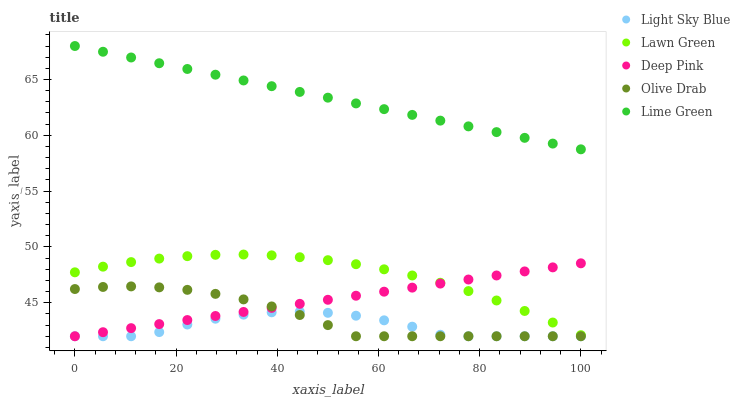Does Light Sky Blue have the minimum area under the curve?
Answer yes or no. Yes. Does Lime Green have the maximum area under the curve?
Answer yes or no. Yes. Does Lime Green have the minimum area under the curve?
Answer yes or no. No. Does Light Sky Blue have the maximum area under the curve?
Answer yes or no. No. Is Deep Pink the smoothest?
Answer yes or no. Yes. Is Light Sky Blue the roughest?
Answer yes or no. Yes. Is Lime Green the smoothest?
Answer yes or no. No. Is Lime Green the roughest?
Answer yes or no. No. Does Light Sky Blue have the lowest value?
Answer yes or no. Yes. Does Lime Green have the lowest value?
Answer yes or no. No. Does Lime Green have the highest value?
Answer yes or no. Yes. Does Light Sky Blue have the highest value?
Answer yes or no. No. Is Deep Pink less than Lime Green?
Answer yes or no. Yes. Is Lime Green greater than Lawn Green?
Answer yes or no. Yes. Does Deep Pink intersect Olive Drab?
Answer yes or no. Yes. Is Deep Pink less than Olive Drab?
Answer yes or no. No. Is Deep Pink greater than Olive Drab?
Answer yes or no. No. Does Deep Pink intersect Lime Green?
Answer yes or no. No. 